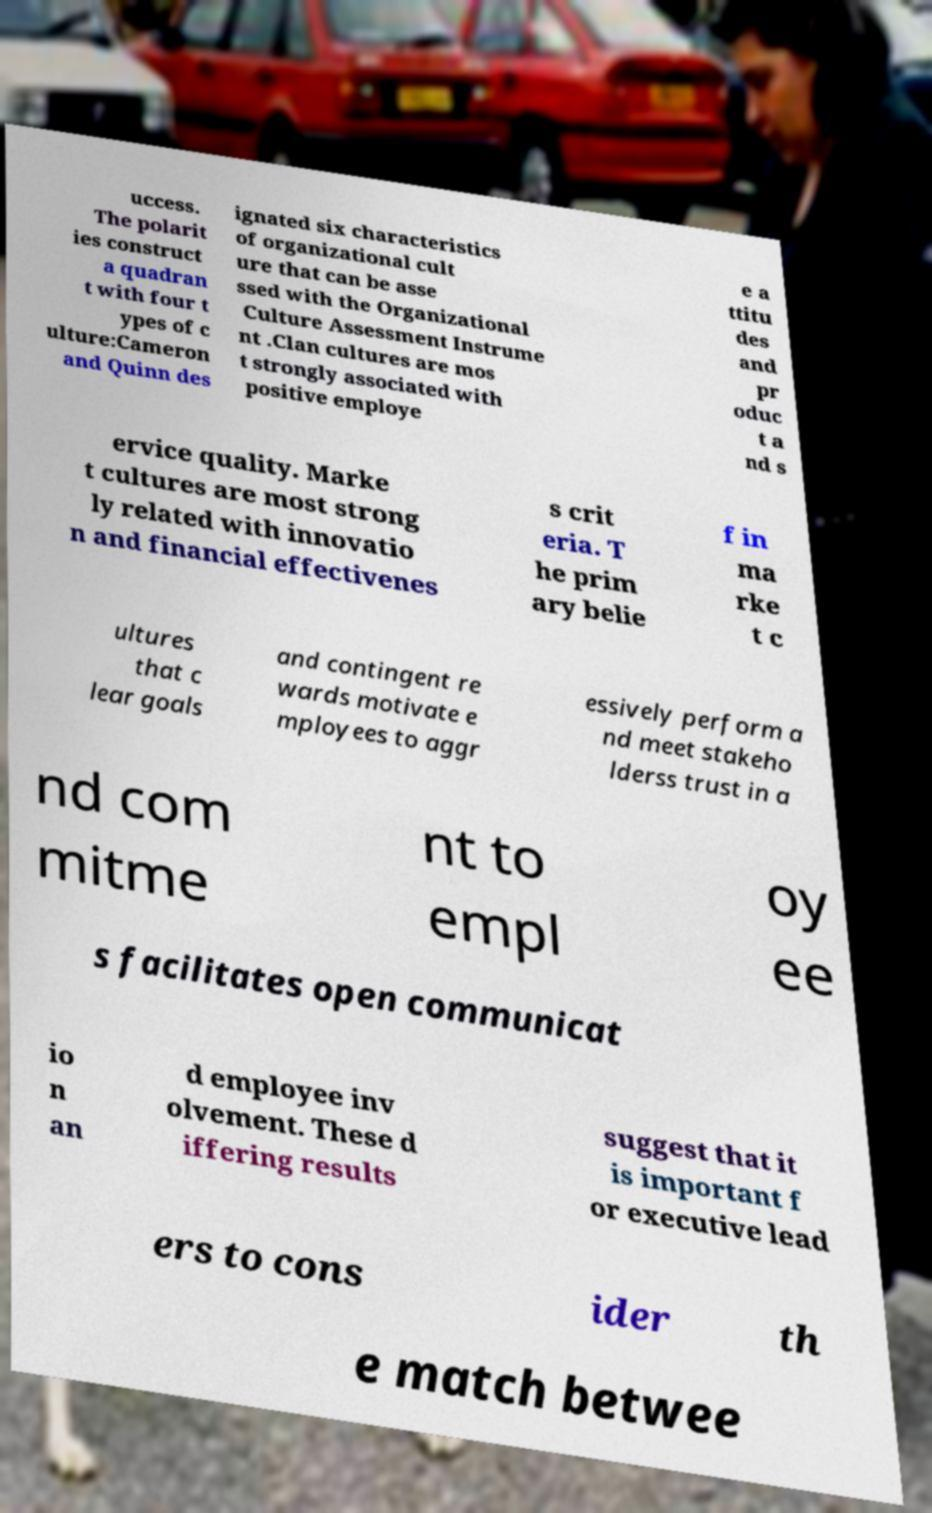Please read and relay the text visible in this image. What does it say? uccess. The polarit ies construct a quadran t with four t ypes of c ulture:Cameron and Quinn des ignated six characteristics of organizational cult ure that can be asse ssed with the Organizational Culture Assessment Instrume nt .Clan cultures are mos t strongly associated with positive employe e a ttitu des and pr oduc t a nd s ervice quality. Marke t cultures are most strong ly related with innovatio n and financial effectivenes s crit eria. T he prim ary belie f in ma rke t c ultures that c lear goals and contingent re wards motivate e mployees to aggr essively perform a nd meet stakeho lderss trust in a nd com mitme nt to empl oy ee s facilitates open communicat io n an d employee inv olvement. These d iffering results suggest that it is important f or executive lead ers to cons ider th e match betwee 